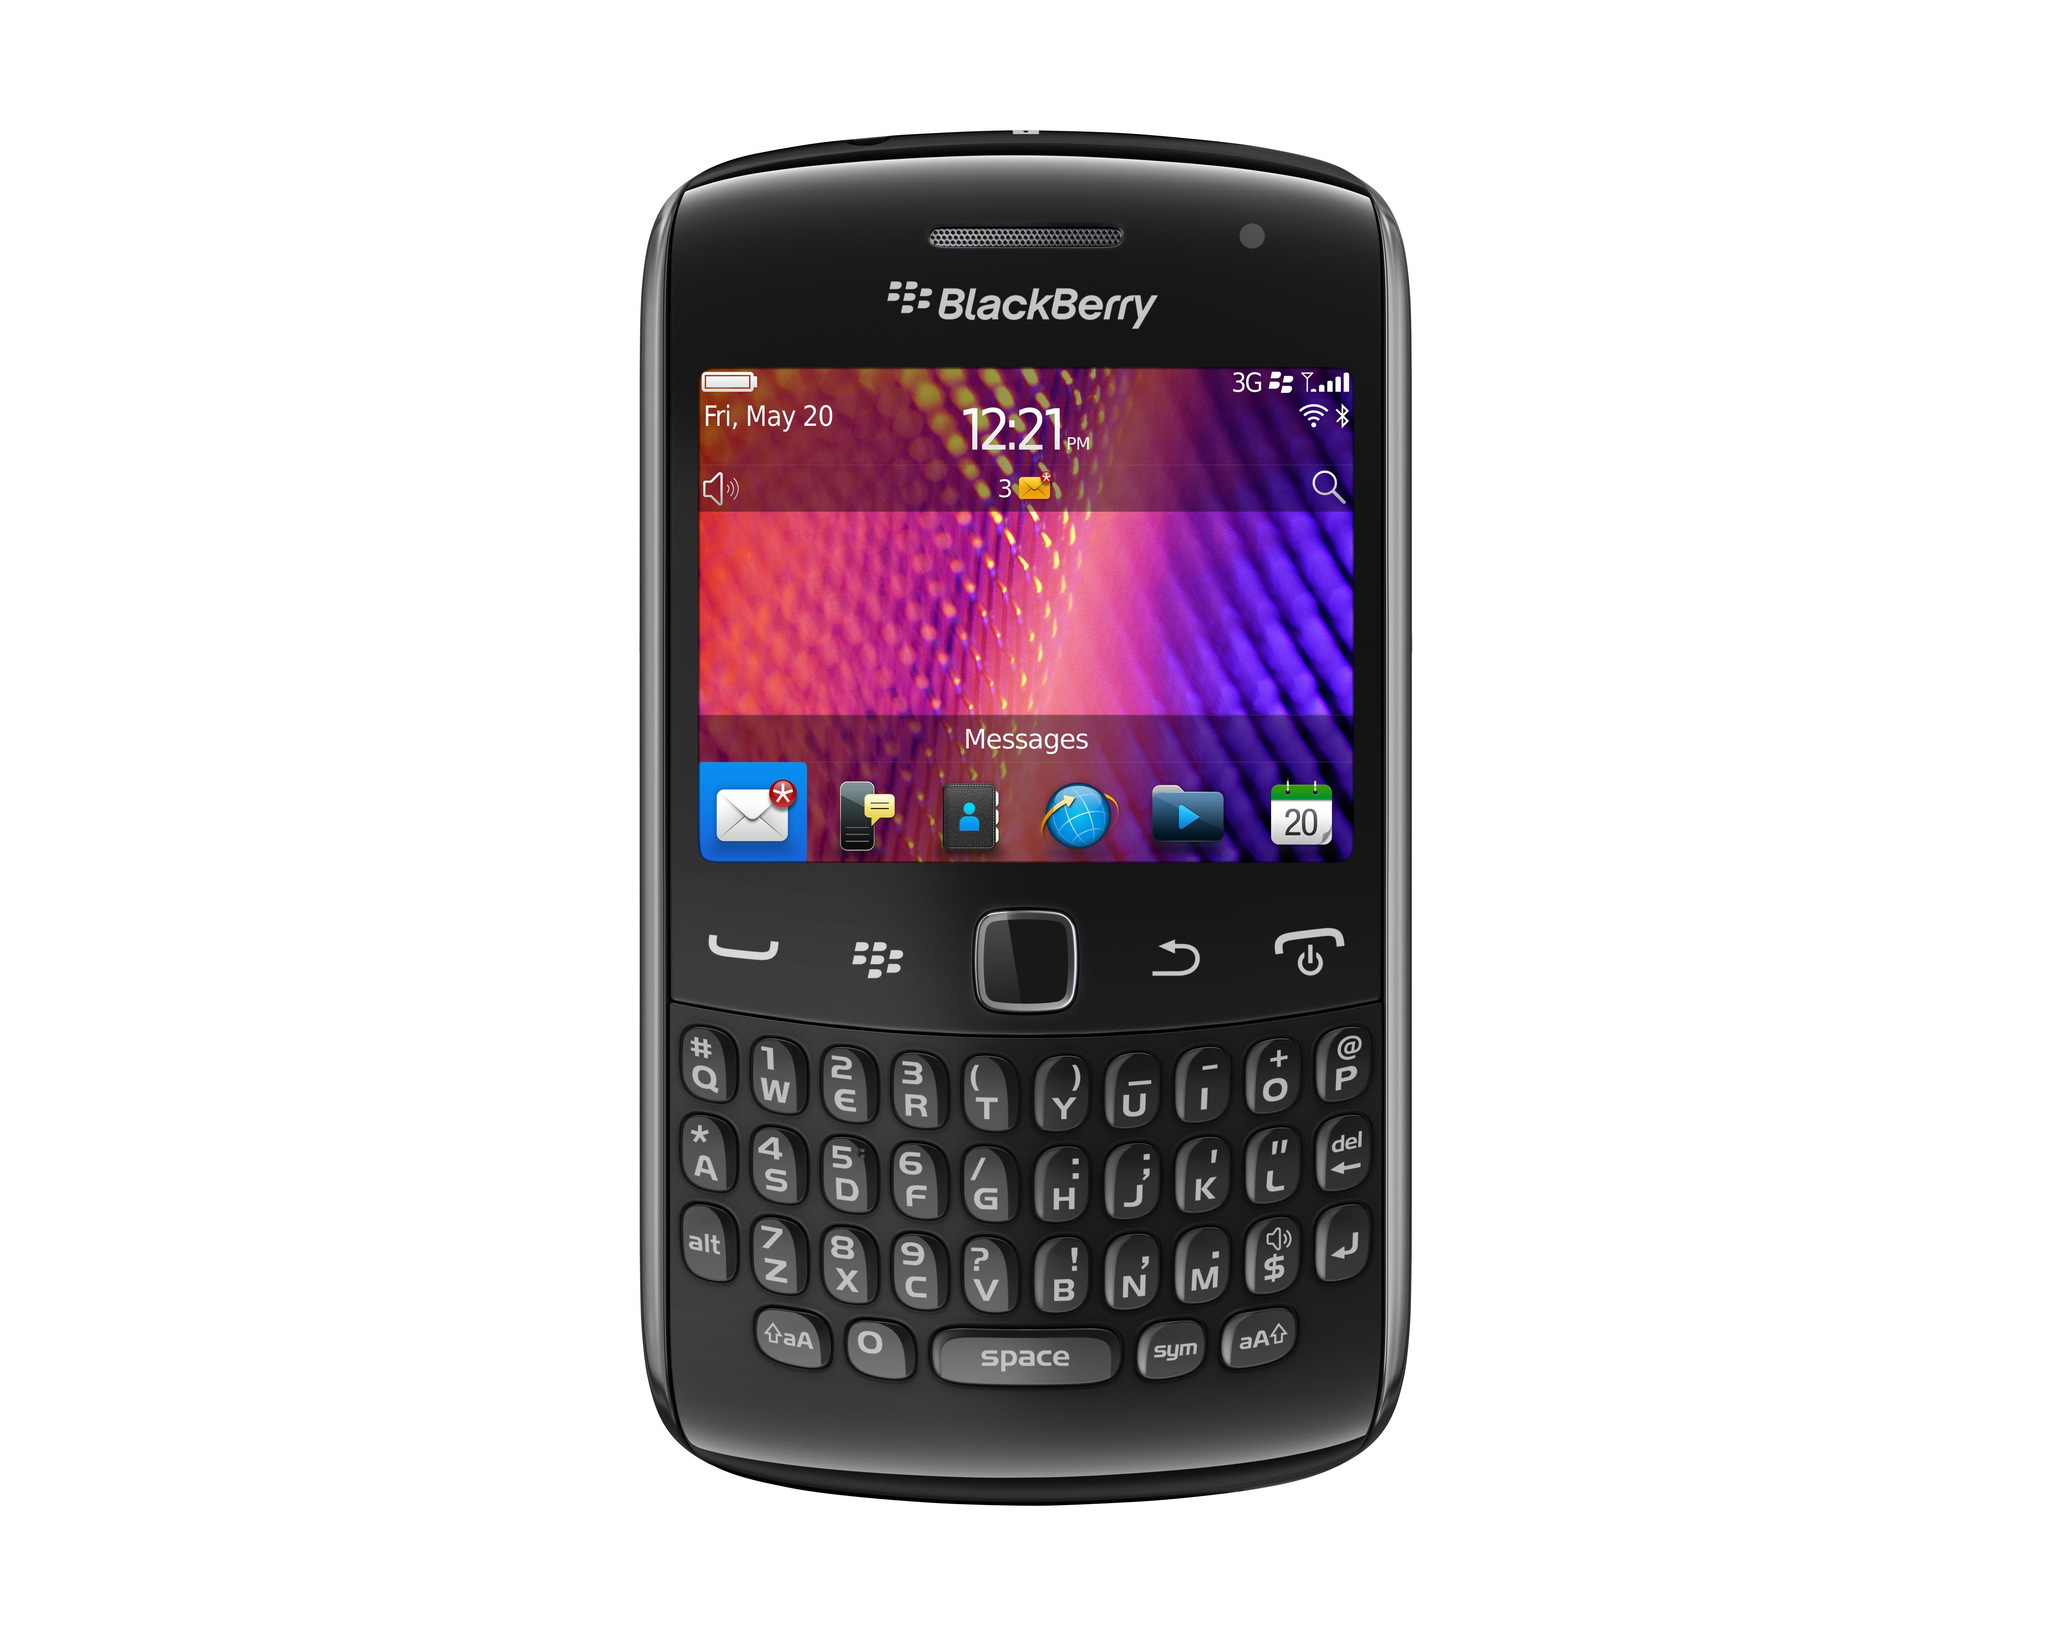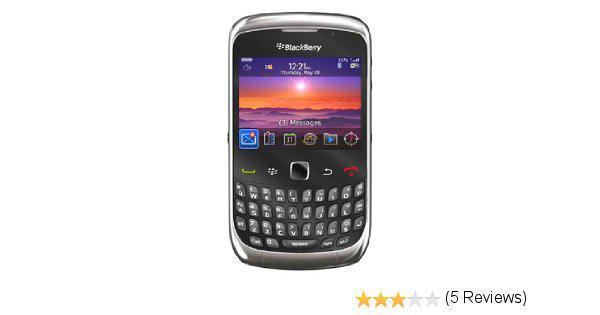The first image is the image on the left, the second image is the image on the right. For the images shown, is this caption "There are a number of stars to the bottom right of one of the phones." true? Answer yes or no. Yes. The first image is the image on the left, the second image is the image on the right. Examine the images to the left and right. Is the description "Both phones display the same time." accurate? Answer yes or no. Yes. 